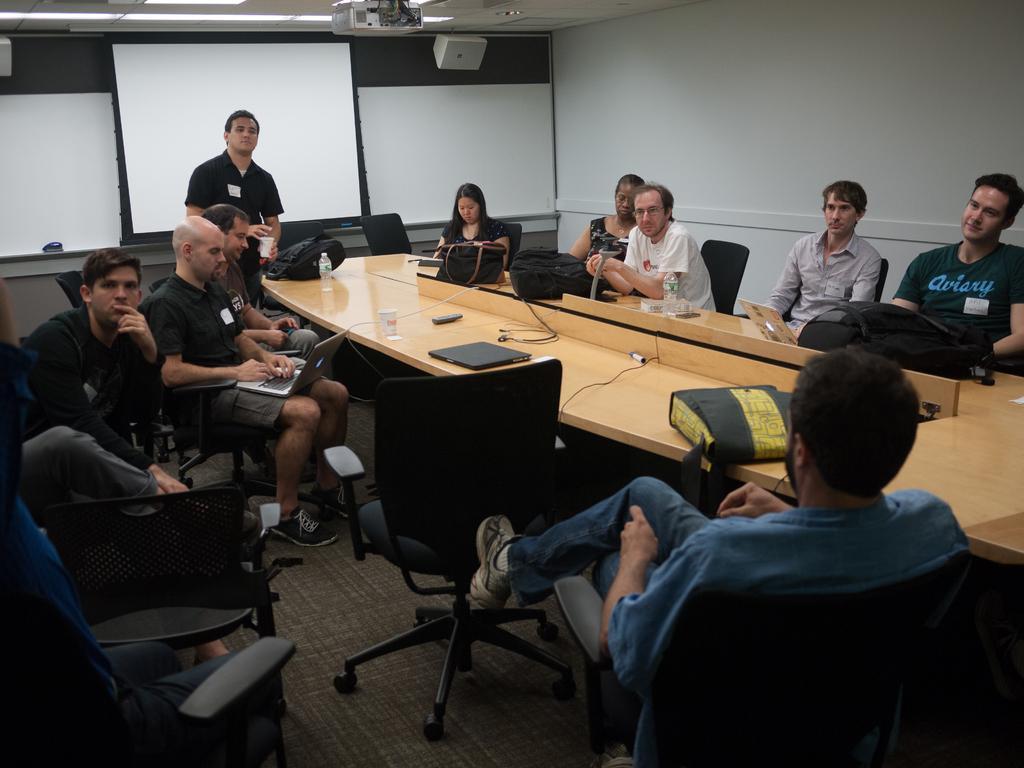Could you give a brief overview of what you see in this image? It is a conference room there are lot of people sitting around the table, some of them are working with their laptops at the end of the table a person is standing, behind him there is a projector in the background there is a white color wall. 